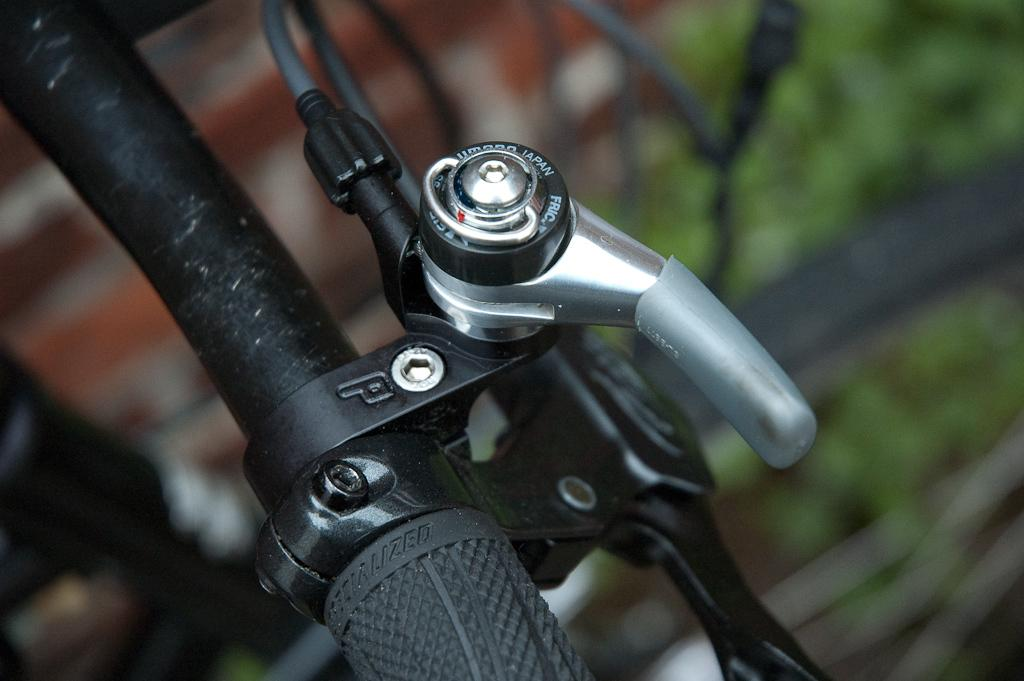What object is featured in the image? There is a handle of a bicycle in the image. Can you describe the object in more detail? The handle is part of a bicycle, which is a mode of transportation. What type of silk fabric is used to make the bicycle handle in the image? There is no silk fabric present in the image; the handle is made of a different material, likely rubber or foam for grip. 